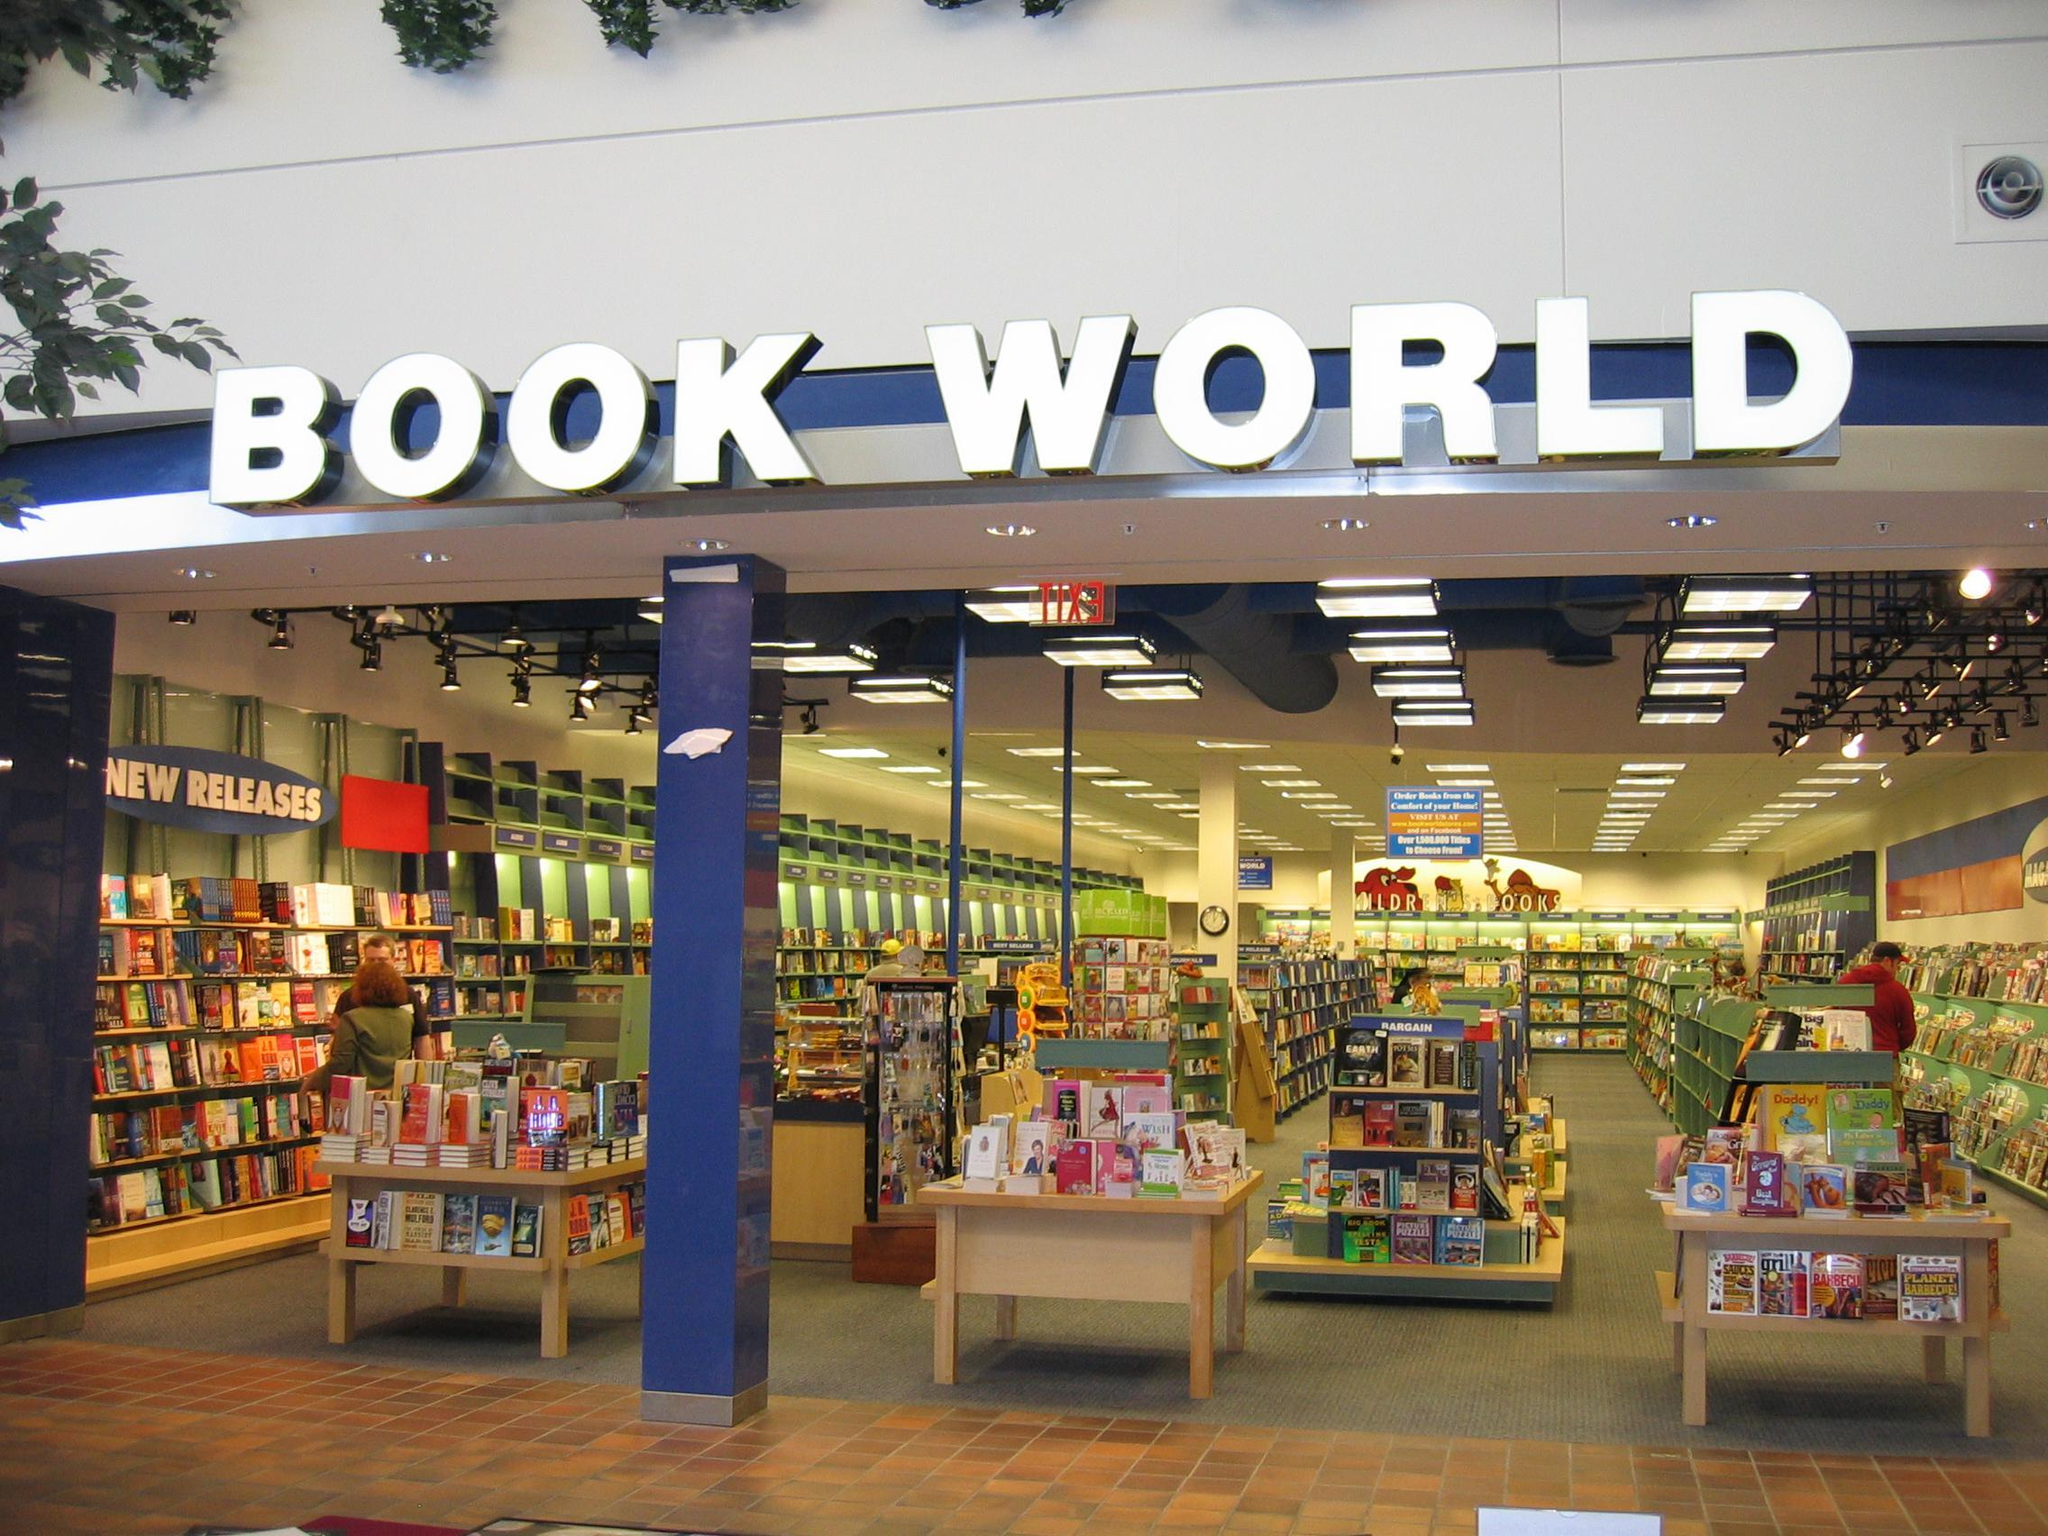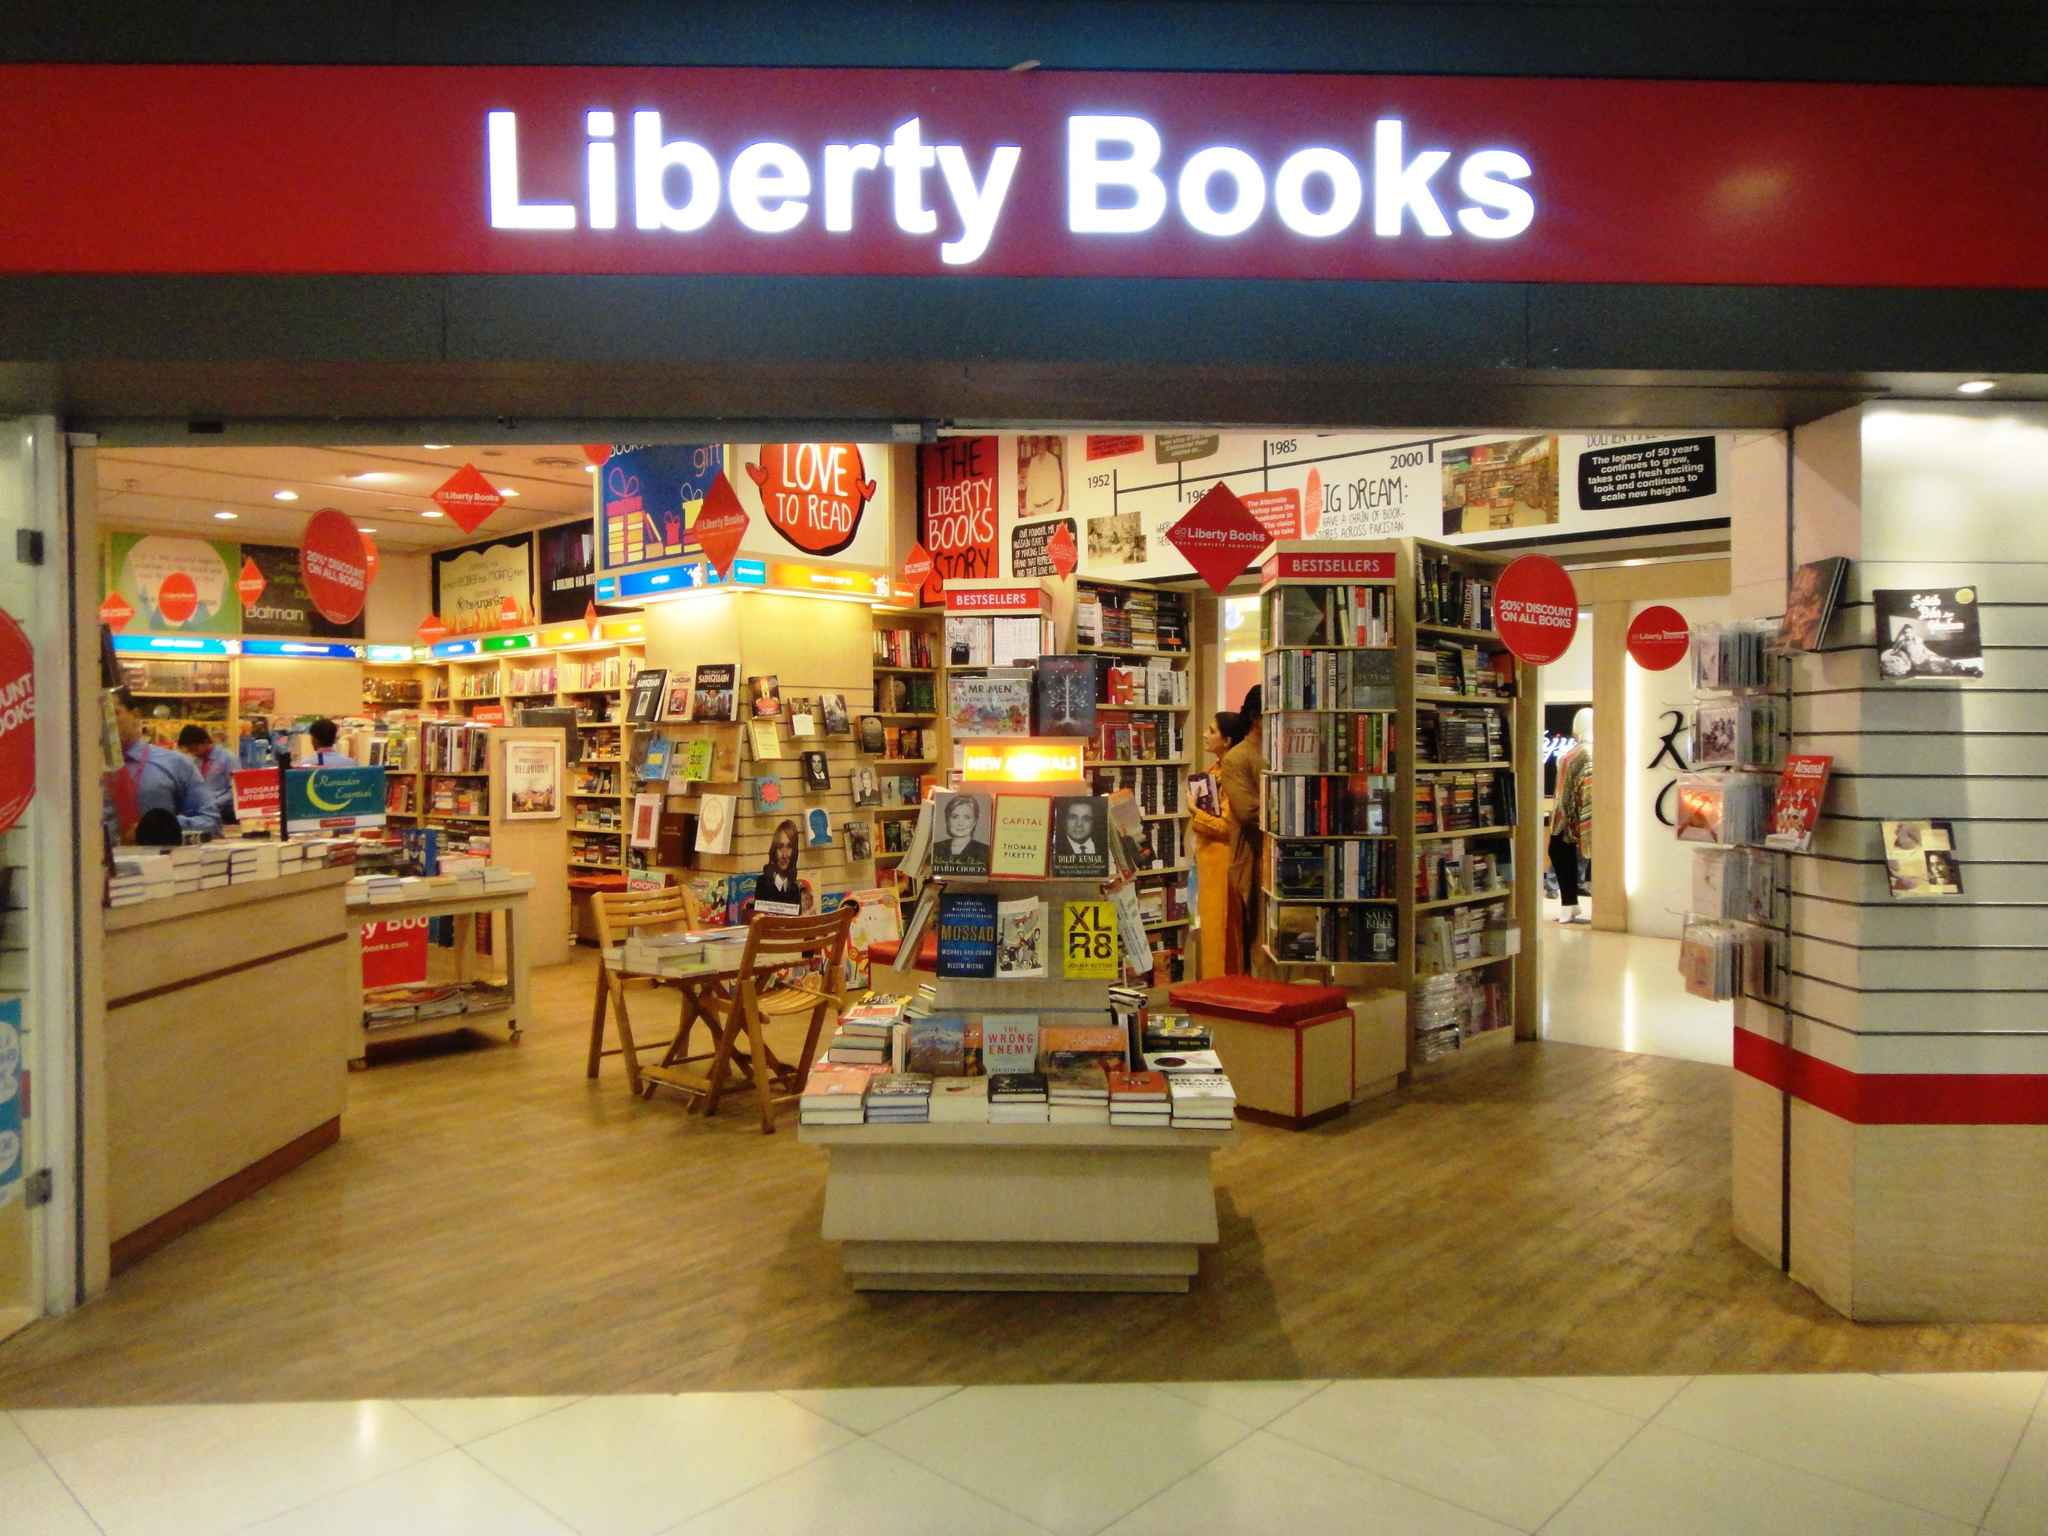The first image is the image on the left, the second image is the image on the right. For the images displayed, is the sentence "An upright blue display stands outside the entry area of one of the stores." factually correct? Answer yes or no. No. 